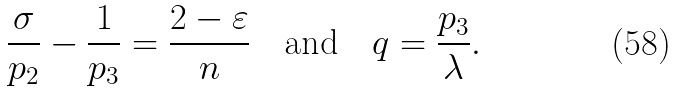Convert formula to latex. <formula><loc_0><loc_0><loc_500><loc_500>\frac { \sigma } { p _ { 2 } } - \frac { 1 } { p _ { 3 } } = \frac { 2 - \varepsilon } { n } \quad \text {and} \quad q = \frac { p _ { 3 } } { \lambda } .</formula> 